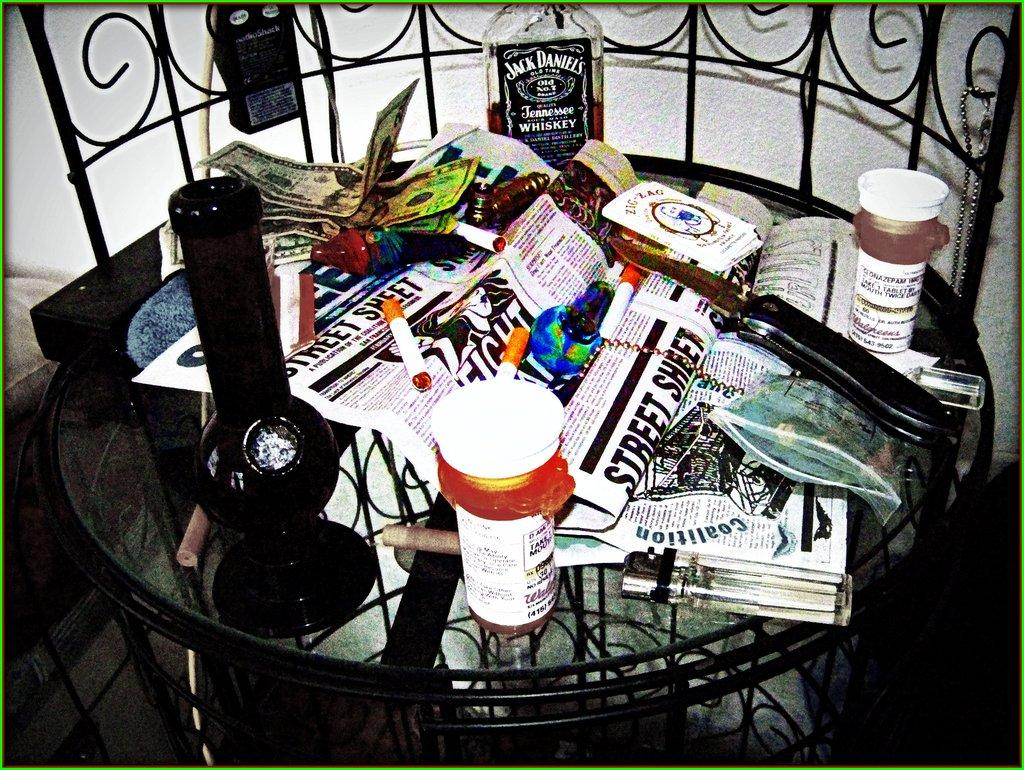What type of furniture is present in the image? There is a table in the image. What objects can be seen on the table? There is a bottle, a pot, cigarettes, papers, a chain, a cover, a knife, a glass, and some dollars on the table. How many slaves are present in the image? There are no slaves present in the image. What level of experience does the frog have in the image? There is no frog present in the image. 